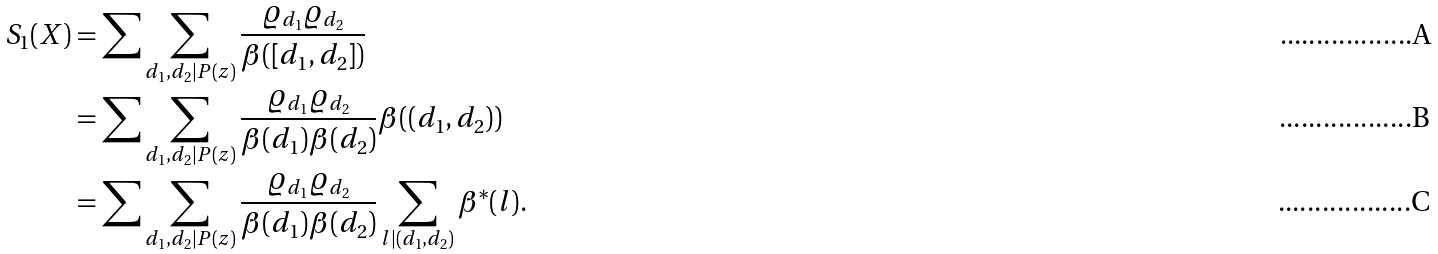Convert formula to latex. <formula><loc_0><loc_0><loc_500><loc_500>S _ { 1 } ( X ) & = \sum \sum _ { d _ { 1 } , d _ { 2 } | P ( z ) } \frac { \varrho _ { d _ { 1 } } \varrho _ { d _ { 2 } } } { \beta ( [ d _ { 1 } , d _ { 2 } ] ) } \\ & = \sum \sum _ { d _ { 1 } , d _ { 2 } | P ( z ) } \frac { \varrho _ { d _ { 1 } } \varrho _ { d _ { 2 } } } { \beta ( d _ { 1 } ) \beta ( d _ { 2 } ) } \beta ( ( d _ { 1 } , d _ { 2 } ) ) \\ & = \sum \sum _ { d _ { 1 } , d _ { 2 } | P ( z ) } \frac { \varrho _ { d _ { 1 } } \varrho _ { d _ { 2 } } } { \beta ( d _ { 1 } ) \beta ( d _ { 2 } ) } \sum _ { l | ( d _ { 1 } , d _ { 2 } ) } \beta ^ { * } ( l ) .</formula> 